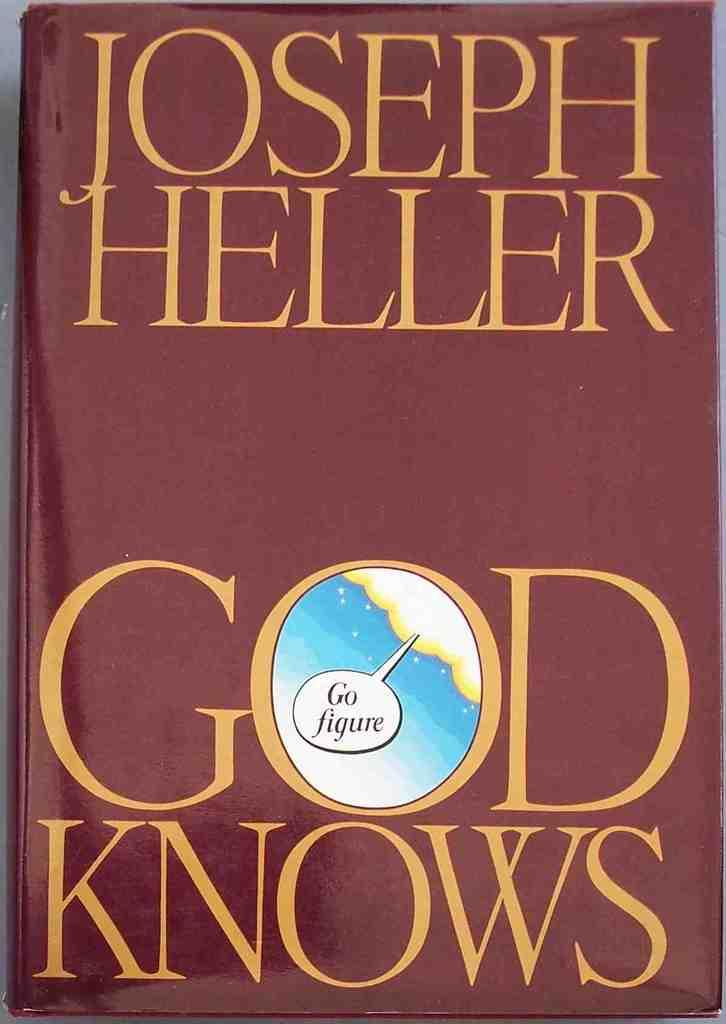<image>
Share a concise interpretation of the image provided. A Book with a garnet cover and gold writing has the title God Knows. 